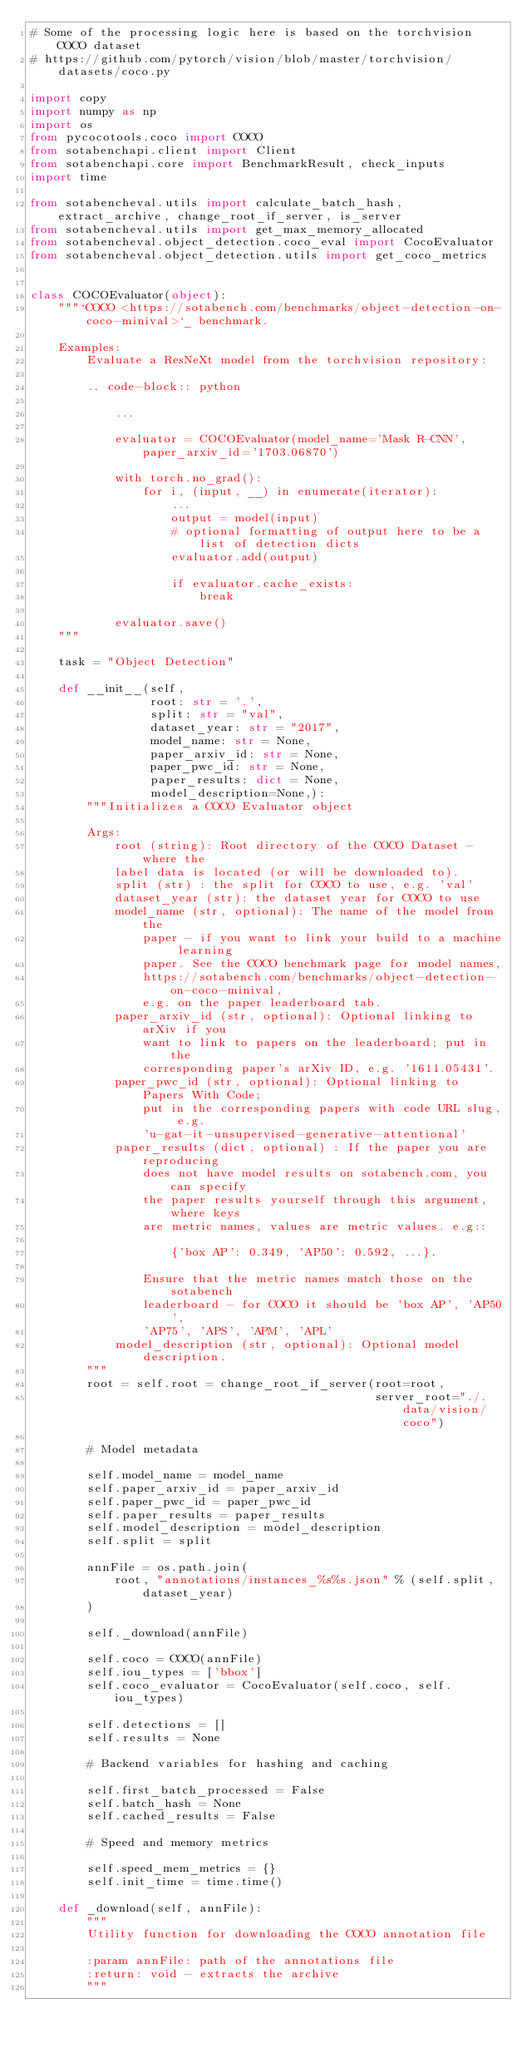<code> <loc_0><loc_0><loc_500><loc_500><_Python_># Some of the processing logic here is based on the torchvision COCO dataset
# https://github.com/pytorch/vision/blob/master/torchvision/datasets/coco.py

import copy
import numpy as np
import os
from pycocotools.coco import COCO
from sotabenchapi.client import Client
from sotabenchapi.core import BenchmarkResult, check_inputs
import time

from sotabencheval.utils import calculate_batch_hash, extract_archive, change_root_if_server, is_server
from sotabencheval.utils import get_max_memory_allocated
from sotabencheval.object_detection.coco_eval import CocoEvaluator
from sotabencheval.object_detection.utils import get_coco_metrics


class COCOEvaluator(object):
    """`COCO <https://sotabench.com/benchmarks/object-detection-on-coco-minival>`_ benchmark.

    Examples:
        Evaluate a ResNeXt model from the torchvision repository:

        .. code-block:: python

            ...

            evaluator = COCOEvaluator(model_name='Mask R-CNN', paper_arxiv_id='1703.06870')

            with torch.no_grad():
                for i, (input, __) in enumerate(iterator):
                    ...
                    output = model(input)
                    # optional formatting of output here to be a list of detection dicts
                    evaluator.add(output)

                    if evaluator.cache_exists:
                        break

            evaluator.save()
    """

    task = "Object Detection"

    def __init__(self,
                 root: str = '.',
                 split: str = "val",
                 dataset_year: str = "2017",
                 model_name: str = None,
                 paper_arxiv_id: str = None,
                 paper_pwc_id: str = None,
                 paper_results: dict = None,
                 model_description=None,):
        """Initializes a COCO Evaluator object

        Args:
            root (string): Root directory of the COCO Dataset - where the
            label data is located (or will be downloaded to).
            split (str) : the split for COCO to use, e.g. 'val'
            dataset_year (str): the dataset year for COCO to use
            model_name (str, optional): The name of the model from the
                paper - if you want to link your build to a machine learning
                paper. See the COCO benchmark page for model names,
                https://sotabench.com/benchmarks/object-detection-on-coco-minival,
                e.g. on the paper leaderboard tab.
            paper_arxiv_id (str, optional): Optional linking to arXiv if you
                want to link to papers on the leaderboard; put in the
                corresponding paper's arXiv ID, e.g. '1611.05431'.
            paper_pwc_id (str, optional): Optional linking to Papers With Code;
                put in the corresponding papers with code URL slug, e.g.
                'u-gat-it-unsupervised-generative-attentional'
            paper_results (dict, optional) : If the paper you are reproducing
                does not have model results on sotabench.com, you can specify
                the paper results yourself through this argument, where keys
                are metric names, values are metric values. e.g::

                    {'box AP': 0.349, 'AP50': 0.592, ...}.

                Ensure that the metric names match those on the sotabench
                leaderboard - for COCO it should be 'box AP', 'AP50',
                'AP75', 'APS', 'APM', 'APL'
            model_description (str, optional): Optional model description.
        """
        root = self.root = change_root_if_server(root=root,
                                                 server_root="./.data/vision/coco")

        # Model metadata

        self.model_name = model_name
        self.paper_arxiv_id = paper_arxiv_id
        self.paper_pwc_id = paper_pwc_id
        self.paper_results = paper_results
        self.model_description = model_description
        self.split = split

        annFile = os.path.join(
            root, "annotations/instances_%s%s.json" % (self.split, dataset_year)
        )

        self._download(annFile)

        self.coco = COCO(annFile)
        self.iou_types = ['bbox']
        self.coco_evaluator = CocoEvaluator(self.coco, self.iou_types)

        self.detections = []
        self.results = None

        # Backend variables for hashing and caching

        self.first_batch_processed = False
        self.batch_hash = None
        self.cached_results = False

        # Speed and memory metrics

        self.speed_mem_metrics = {}
        self.init_time = time.time()

    def _download(self, annFile):
        """
        Utility function for downloading the COCO annotation file

        :param annFile: path of the annotations file
        :return: void - extracts the archive
        """</code> 